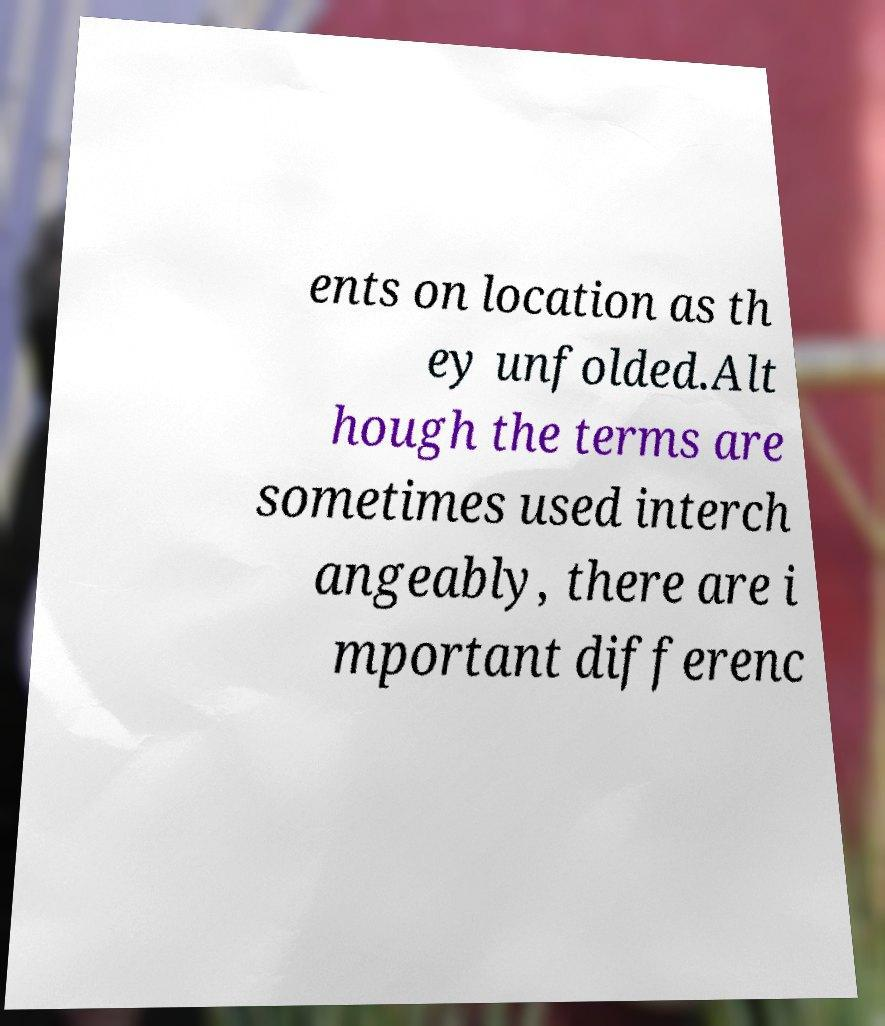There's text embedded in this image that I need extracted. Can you transcribe it verbatim? ents on location as th ey unfolded.Alt hough the terms are sometimes used interch angeably, there are i mportant differenc 